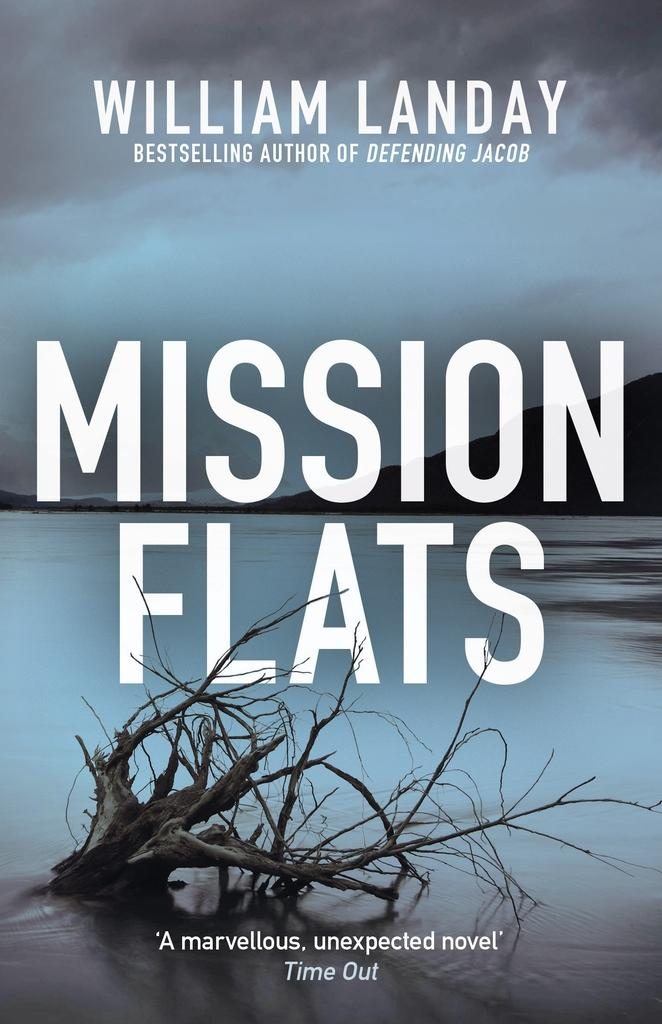<image>
Relay a brief, clear account of the picture shown. The novel Mission Flats was well reviewed by Time Out magazine. 